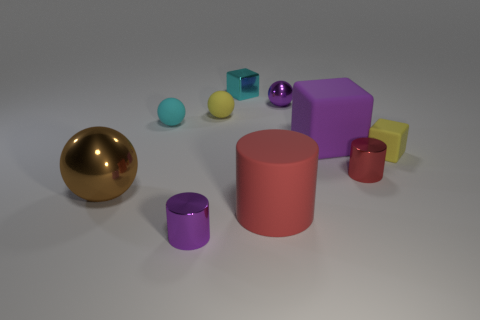Subtract all blue cubes. Subtract all green spheres. How many cubes are left? 3 Subtract all balls. How many objects are left? 6 Subtract all large shiny balls. Subtract all cyan rubber things. How many objects are left? 8 Add 3 small yellow cubes. How many small yellow cubes are left? 4 Add 2 cyan spheres. How many cyan spheres exist? 3 Subtract 0 brown cylinders. How many objects are left? 10 